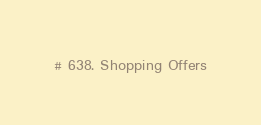Convert code to text. <code><loc_0><loc_0><loc_500><loc_500><_Python_># 638. Shopping Offers

</code> 